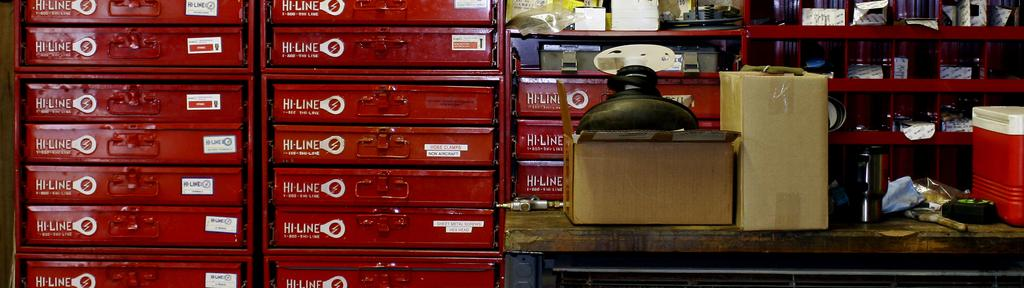<image>
Relay a brief, clear account of the picture shown. Rows of Hi-Line red trays next to a table with boxes on top. 